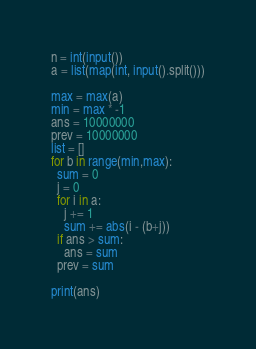<code> <loc_0><loc_0><loc_500><loc_500><_Python_>n = int(input())
a = list(map(int, input().split()))

max = max(a)
min = max * -1
ans = 10000000
prev = 10000000
list = []
for b in range(min,max):
  sum = 0
  j = 0
  for i in a:
    j += 1
    sum += abs(i - (b+j))
  if ans > sum:
    ans = sum
  prev = sum

print(ans)</code> 